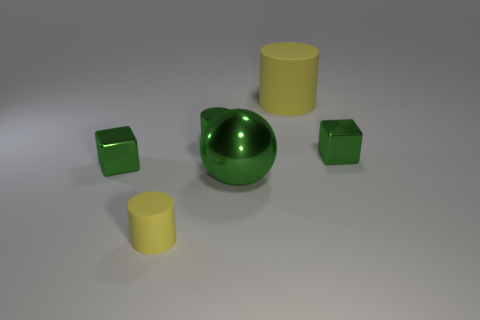Subtract all matte cylinders. How many cylinders are left? 1 Subtract all yellow cubes. How many yellow cylinders are left? 2 Subtract 1 cylinders. How many cylinders are left? 2 Add 4 green cylinders. How many objects exist? 10 Subtract all spheres. How many objects are left? 5 Add 6 green metallic cylinders. How many green metallic cylinders exist? 7 Subtract 0 gray balls. How many objects are left? 6 Subtract all matte cylinders. Subtract all blue rubber things. How many objects are left? 4 Add 2 big balls. How many big balls are left? 3 